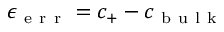<formula> <loc_0><loc_0><loc_500><loc_500>\epsilon _ { e r r } = c _ { + } - c _ { b u l k }</formula> 